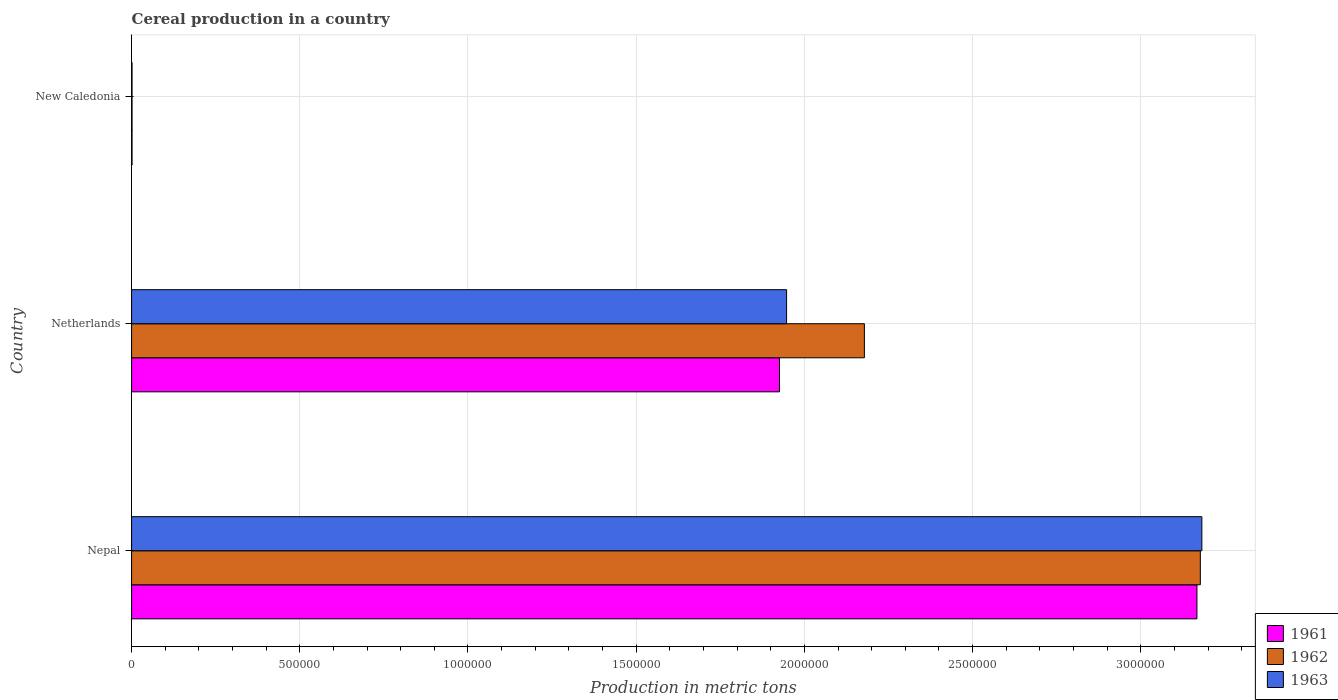How many different coloured bars are there?
Provide a succinct answer. 3. How many groups of bars are there?
Your response must be concise. 3. Are the number of bars on each tick of the Y-axis equal?
Provide a succinct answer. Yes. How many bars are there on the 1st tick from the top?
Ensure brevity in your answer.  3. What is the label of the 3rd group of bars from the top?
Make the answer very short. Nepal. What is the total cereal production in 1963 in Netherlands?
Your answer should be very brief. 1.95e+06. Across all countries, what is the maximum total cereal production in 1963?
Your answer should be very brief. 3.18e+06. Across all countries, what is the minimum total cereal production in 1963?
Your answer should be compact. 1380. In which country was the total cereal production in 1963 maximum?
Make the answer very short. Nepal. In which country was the total cereal production in 1961 minimum?
Your response must be concise. New Caledonia. What is the total total cereal production in 1961 in the graph?
Offer a terse response. 5.09e+06. What is the difference between the total cereal production in 1963 in Netherlands and that in New Caledonia?
Provide a short and direct response. 1.95e+06. What is the difference between the total cereal production in 1961 in Nepal and the total cereal production in 1962 in New Caledonia?
Make the answer very short. 3.17e+06. What is the average total cereal production in 1963 per country?
Offer a very short reply. 1.71e+06. What is the difference between the total cereal production in 1962 and total cereal production in 1963 in New Caledonia?
Offer a terse response. 0. In how many countries, is the total cereal production in 1963 greater than 2600000 metric tons?
Offer a terse response. 1. What is the ratio of the total cereal production in 1961 in Nepal to that in New Caledonia?
Give a very brief answer. 2294.93. What is the difference between the highest and the second highest total cereal production in 1962?
Ensure brevity in your answer.  9.99e+05. What is the difference between the highest and the lowest total cereal production in 1962?
Your response must be concise. 3.18e+06. In how many countries, is the total cereal production in 1962 greater than the average total cereal production in 1962 taken over all countries?
Keep it short and to the point. 2. What does the 2nd bar from the top in Netherlands represents?
Make the answer very short. 1962. What does the 3rd bar from the bottom in New Caledonia represents?
Provide a succinct answer. 1963. Is it the case that in every country, the sum of the total cereal production in 1962 and total cereal production in 1961 is greater than the total cereal production in 1963?
Ensure brevity in your answer.  Yes. How many bars are there?
Offer a terse response. 9. Are all the bars in the graph horizontal?
Make the answer very short. Yes. Does the graph contain any zero values?
Provide a short and direct response. No. How are the legend labels stacked?
Make the answer very short. Vertical. What is the title of the graph?
Give a very brief answer. Cereal production in a country. Does "1967" appear as one of the legend labels in the graph?
Provide a short and direct response. No. What is the label or title of the X-axis?
Provide a succinct answer. Production in metric tons. What is the label or title of the Y-axis?
Your answer should be compact. Country. What is the Production in metric tons in 1961 in Nepal?
Offer a terse response. 3.17e+06. What is the Production in metric tons of 1962 in Nepal?
Your answer should be compact. 3.18e+06. What is the Production in metric tons of 1963 in Nepal?
Offer a very short reply. 3.18e+06. What is the Production in metric tons in 1961 in Netherlands?
Provide a short and direct response. 1.93e+06. What is the Production in metric tons in 1962 in Netherlands?
Keep it short and to the point. 2.18e+06. What is the Production in metric tons of 1963 in Netherlands?
Your answer should be very brief. 1.95e+06. What is the Production in metric tons in 1961 in New Caledonia?
Give a very brief answer. 1380. What is the Production in metric tons of 1962 in New Caledonia?
Give a very brief answer. 1380. What is the Production in metric tons in 1963 in New Caledonia?
Offer a very short reply. 1380. Across all countries, what is the maximum Production in metric tons of 1961?
Keep it short and to the point. 3.17e+06. Across all countries, what is the maximum Production in metric tons of 1962?
Give a very brief answer. 3.18e+06. Across all countries, what is the maximum Production in metric tons of 1963?
Offer a very short reply. 3.18e+06. Across all countries, what is the minimum Production in metric tons of 1961?
Your response must be concise. 1380. Across all countries, what is the minimum Production in metric tons in 1962?
Give a very brief answer. 1380. Across all countries, what is the minimum Production in metric tons of 1963?
Your answer should be very brief. 1380. What is the total Production in metric tons in 1961 in the graph?
Ensure brevity in your answer.  5.09e+06. What is the total Production in metric tons in 1962 in the graph?
Keep it short and to the point. 5.36e+06. What is the total Production in metric tons in 1963 in the graph?
Your answer should be compact. 5.13e+06. What is the difference between the Production in metric tons of 1961 in Nepal and that in Netherlands?
Provide a succinct answer. 1.24e+06. What is the difference between the Production in metric tons of 1962 in Nepal and that in Netherlands?
Keep it short and to the point. 9.99e+05. What is the difference between the Production in metric tons in 1963 in Nepal and that in Netherlands?
Provide a succinct answer. 1.23e+06. What is the difference between the Production in metric tons of 1961 in Nepal and that in New Caledonia?
Provide a succinct answer. 3.17e+06. What is the difference between the Production in metric tons of 1962 in Nepal and that in New Caledonia?
Offer a terse response. 3.18e+06. What is the difference between the Production in metric tons of 1963 in Nepal and that in New Caledonia?
Give a very brief answer. 3.18e+06. What is the difference between the Production in metric tons in 1961 in Netherlands and that in New Caledonia?
Ensure brevity in your answer.  1.92e+06. What is the difference between the Production in metric tons in 1962 in Netherlands and that in New Caledonia?
Keep it short and to the point. 2.18e+06. What is the difference between the Production in metric tons in 1963 in Netherlands and that in New Caledonia?
Your answer should be compact. 1.95e+06. What is the difference between the Production in metric tons of 1961 in Nepal and the Production in metric tons of 1962 in Netherlands?
Offer a very short reply. 9.89e+05. What is the difference between the Production in metric tons of 1961 in Nepal and the Production in metric tons of 1963 in Netherlands?
Your response must be concise. 1.22e+06. What is the difference between the Production in metric tons in 1962 in Nepal and the Production in metric tons in 1963 in Netherlands?
Your response must be concise. 1.23e+06. What is the difference between the Production in metric tons of 1961 in Nepal and the Production in metric tons of 1962 in New Caledonia?
Your response must be concise. 3.17e+06. What is the difference between the Production in metric tons in 1961 in Nepal and the Production in metric tons in 1963 in New Caledonia?
Your response must be concise. 3.17e+06. What is the difference between the Production in metric tons of 1962 in Nepal and the Production in metric tons of 1963 in New Caledonia?
Your response must be concise. 3.18e+06. What is the difference between the Production in metric tons in 1961 in Netherlands and the Production in metric tons in 1962 in New Caledonia?
Give a very brief answer. 1.92e+06. What is the difference between the Production in metric tons in 1961 in Netherlands and the Production in metric tons in 1963 in New Caledonia?
Your response must be concise. 1.92e+06. What is the difference between the Production in metric tons in 1962 in Netherlands and the Production in metric tons in 1963 in New Caledonia?
Provide a short and direct response. 2.18e+06. What is the average Production in metric tons in 1961 per country?
Make the answer very short. 1.70e+06. What is the average Production in metric tons in 1962 per country?
Give a very brief answer. 1.79e+06. What is the average Production in metric tons of 1963 per country?
Provide a succinct answer. 1.71e+06. What is the difference between the Production in metric tons of 1961 and Production in metric tons of 1962 in Nepal?
Your answer should be compact. -1.00e+04. What is the difference between the Production in metric tons of 1961 and Production in metric tons of 1963 in Nepal?
Offer a terse response. -1.46e+04. What is the difference between the Production in metric tons in 1962 and Production in metric tons in 1963 in Nepal?
Provide a short and direct response. -4552. What is the difference between the Production in metric tons of 1961 and Production in metric tons of 1962 in Netherlands?
Give a very brief answer. -2.52e+05. What is the difference between the Production in metric tons of 1961 and Production in metric tons of 1963 in Netherlands?
Keep it short and to the point. -2.11e+04. What is the difference between the Production in metric tons of 1962 and Production in metric tons of 1963 in Netherlands?
Offer a terse response. 2.31e+05. What is the difference between the Production in metric tons of 1961 and Production in metric tons of 1962 in New Caledonia?
Ensure brevity in your answer.  0. What is the difference between the Production in metric tons of 1961 and Production in metric tons of 1963 in New Caledonia?
Offer a very short reply. 0. What is the difference between the Production in metric tons in 1962 and Production in metric tons in 1963 in New Caledonia?
Offer a very short reply. 0. What is the ratio of the Production in metric tons in 1961 in Nepal to that in Netherlands?
Offer a terse response. 1.64. What is the ratio of the Production in metric tons in 1962 in Nepal to that in Netherlands?
Provide a succinct answer. 1.46. What is the ratio of the Production in metric tons in 1963 in Nepal to that in Netherlands?
Provide a succinct answer. 1.63. What is the ratio of the Production in metric tons of 1961 in Nepal to that in New Caledonia?
Your response must be concise. 2294.93. What is the ratio of the Production in metric tons in 1962 in Nepal to that in New Caledonia?
Provide a succinct answer. 2302.19. What is the ratio of the Production in metric tons of 1963 in Nepal to that in New Caledonia?
Give a very brief answer. 2305.49. What is the ratio of the Production in metric tons in 1961 in Netherlands to that in New Caledonia?
Provide a short and direct response. 1395.67. What is the ratio of the Production in metric tons of 1962 in Netherlands to that in New Caledonia?
Your response must be concise. 1578.57. What is the ratio of the Production in metric tons in 1963 in Netherlands to that in New Caledonia?
Keep it short and to the point. 1410.93. What is the difference between the highest and the second highest Production in metric tons in 1961?
Keep it short and to the point. 1.24e+06. What is the difference between the highest and the second highest Production in metric tons in 1962?
Your answer should be very brief. 9.99e+05. What is the difference between the highest and the second highest Production in metric tons in 1963?
Give a very brief answer. 1.23e+06. What is the difference between the highest and the lowest Production in metric tons of 1961?
Your response must be concise. 3.17e+06. What is the difference between the highest and the lowest Production in metric tons of 1962?
Keep it short and to the point. 3.18e+06. What is the difference between the highest and the lowest Production in metric tons of 1963?
Your response must be concise. 3.18e+06. 